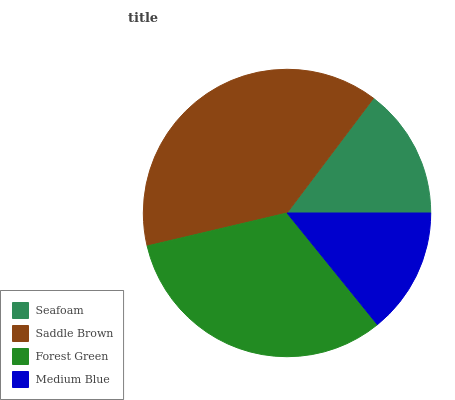Is Medium Blue the minimum?
Answer yes or no. Yes. Is Saddle Brown the maximum?
Answer yes or no. Yes. Is Forest Green the minimum?
Answer yes or no. No. Is Forest Green the maximum?
Answer yes or no. No. Is Saddle Brown greater than Forest Green?
Answer yes or no. Yes. Is Forest Green less than Saddle Brown?
Answer yes or no. Yes. Is Forest Green greater than Saddle Brown?
Answer yes or no. No. Is Saddle Brown less than Forest Green?
Answer yes or no. No. Is Forest Green the high median?
Answer yes or no. Yes. Is Seafoam the low median?
Answer yes or no. Yes. Is Medium Blue the high median?
Answer yes or no. No. Is Saddle Brown the low median?
Answer yes or no. No. 